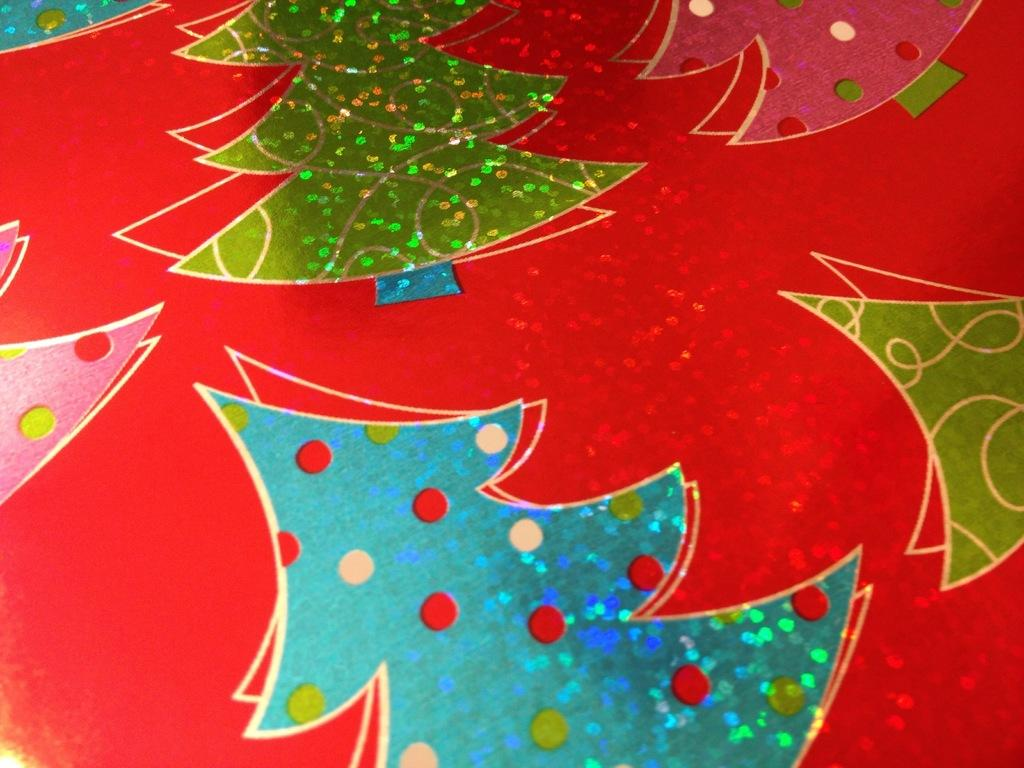What type of trees are depicted in the image? There are Christmas trees in the image. How are the Christmas trees decorated? The Christmas trees are glittering. Where are the Christmas trees located? The Christmas trees are on a card. How many eggs are hidden behind the Christmas trees in the image? There are no eggs present in the image; it only features glittering Christmas trees on a card. 